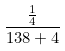Convert formula to latex. <formula><loc_0><loc_0><loc_500><loc_500>\frac { \frac { 1 } { 4 } } { 1 3 8 + 4 }</formula> 